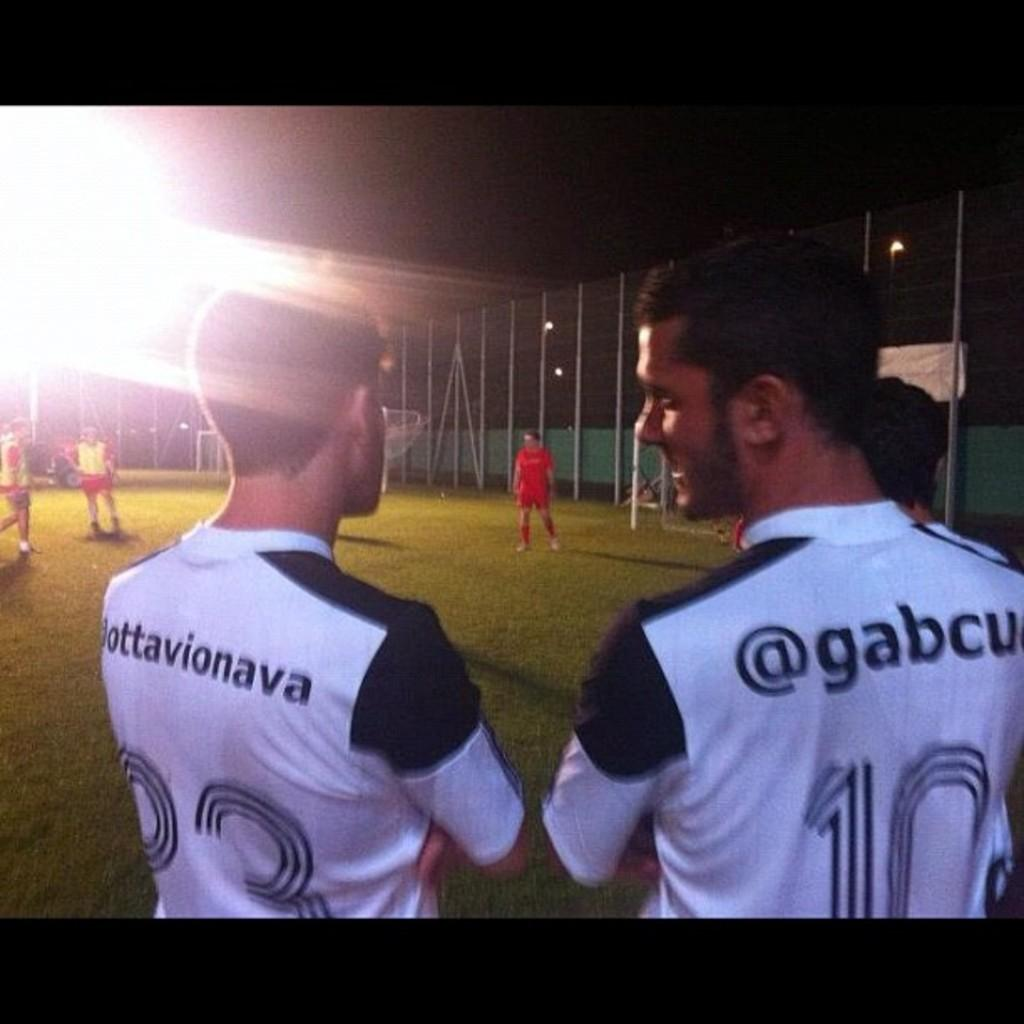<image>
Present a compact description of the photo's key features. a couple of jerseys with one that has the number ten on it 